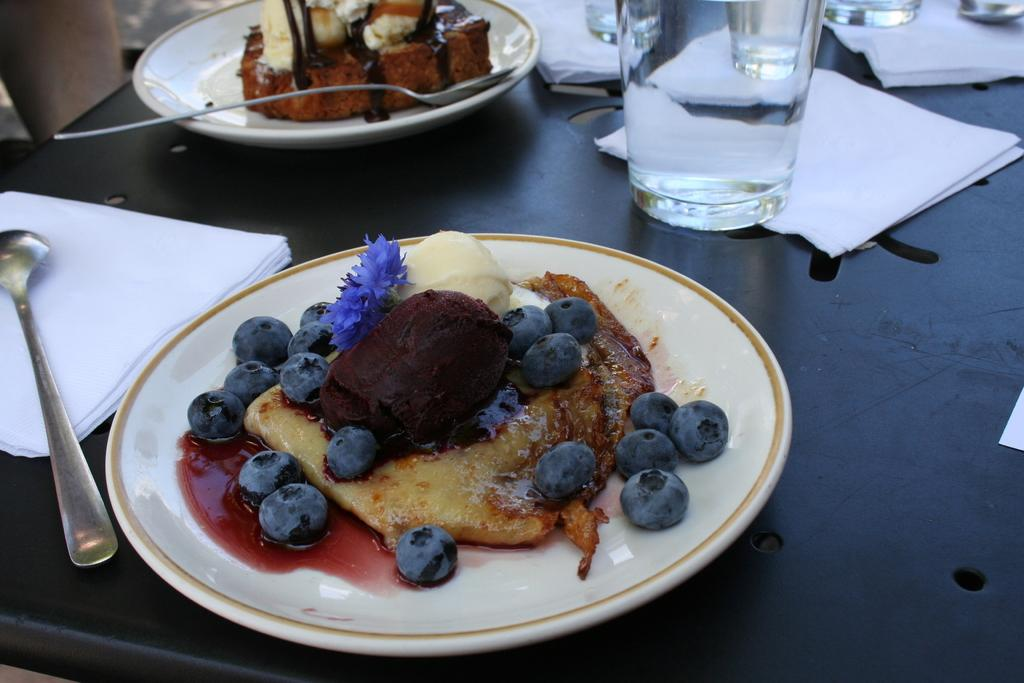What type of food items can be seen on plates in the image? There are food items on plates in the image, but the specific types of food are not mentioned. What can be used for cleaning or wiping in the image? Tissues are present in the image for cleaning or wiping. What utensil is visible in the image? There is a spoon in the image. What type of container is present in the image? There are glasses in the image. Where are all these items located? All of these items are on a table in the image. What type of guitar is being played by the person in the image? There is no person or guitar present in the image; it only features food items on plates, tissues, a spoon, glasses, and a table. What organization is responsible for arranging the dinner in the image? There is no dinner or organization mentioned in the image; it only features food items on plates, tissues, a spoon, glasses, and a table. 